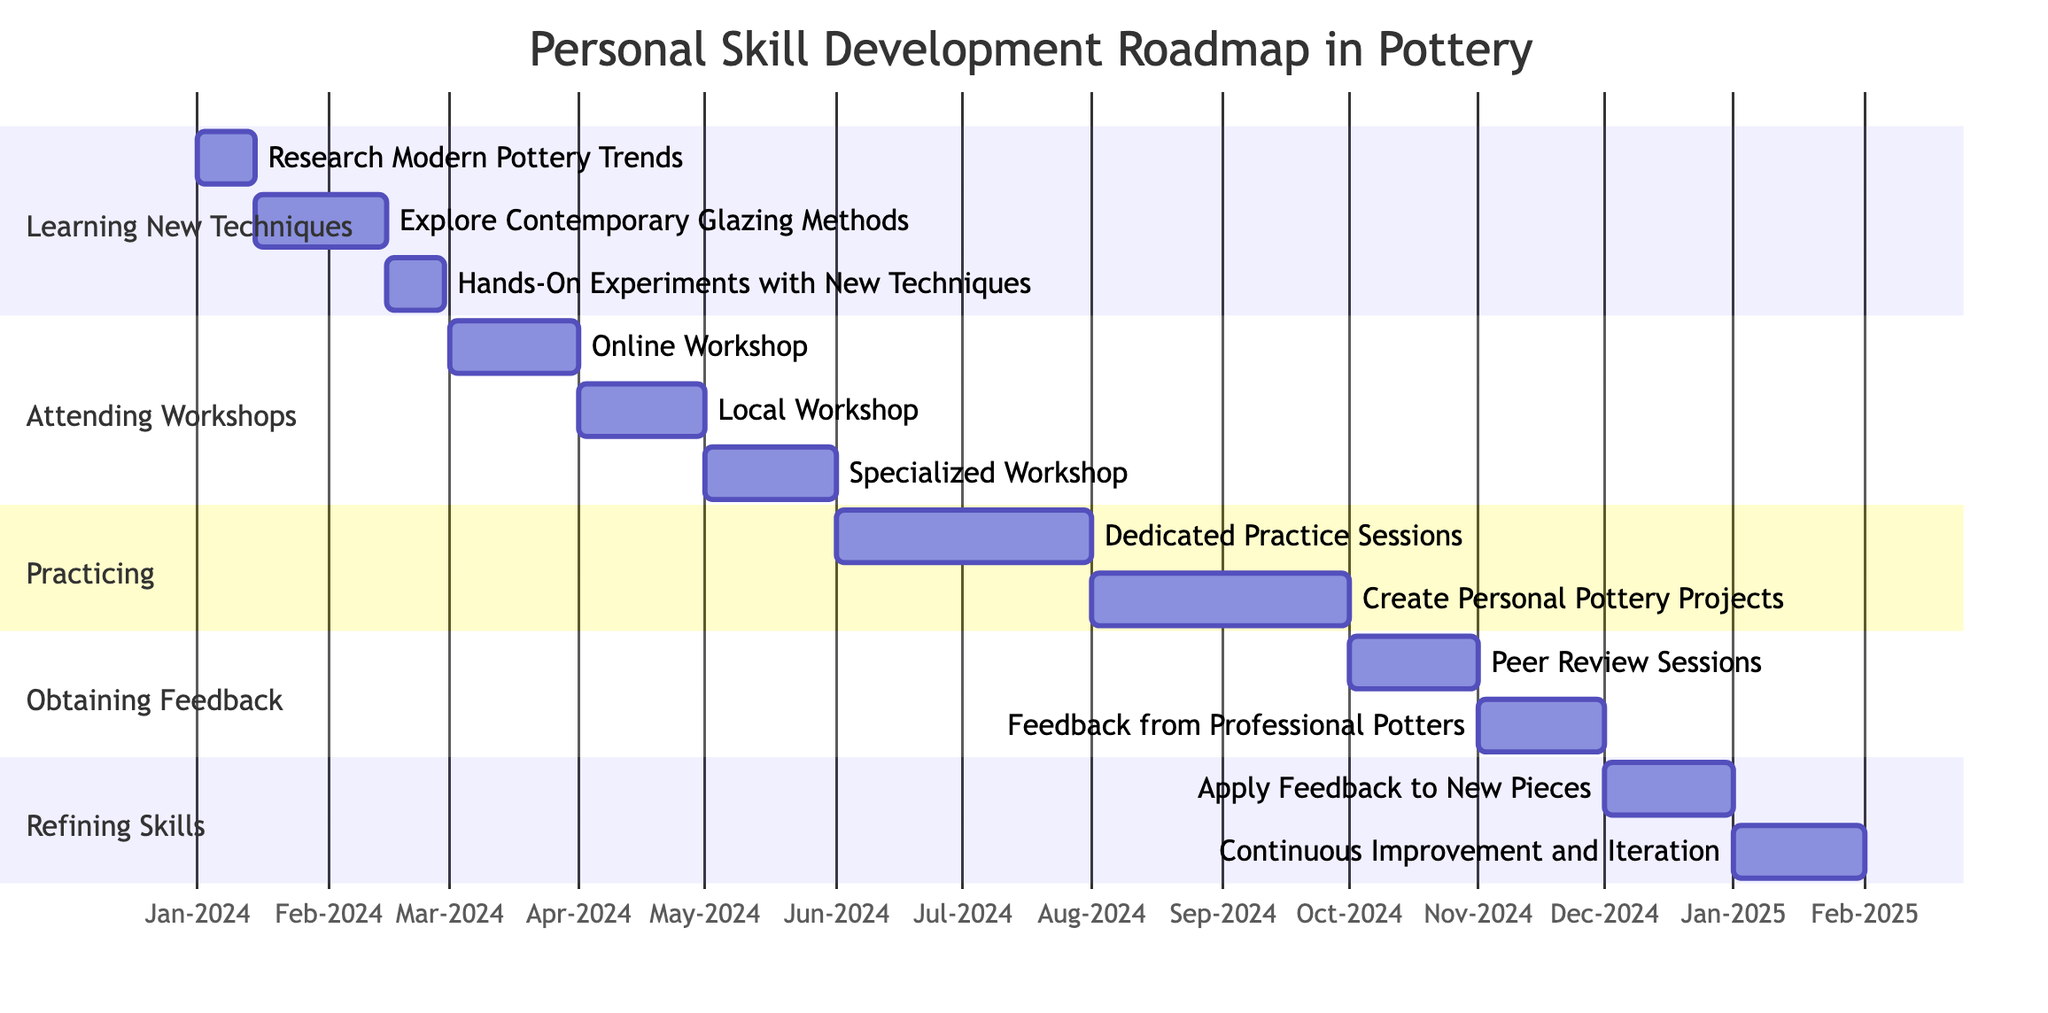What is the duration for the 'Learning New Techniques' section? The duration for the 'Learning New Techniques' section, as specified in the diagram, is 2 months.
Answer: 2 months How many tasks are in the 'Practicing' section? The 'Practicing' section contains 2 tasks: "Dedicated Practice Sessions" and "Create Personal Pottery Projects." Counting these gives a total of 2 tasks.
Answer: 2 What is the next task after 'Peer Review Sessions'? The task that follows 'Peer Review Sessions' is 'Feedback from Professional Potters' according to the timeline sequence laid out in the Gantt chart.
Answer: Feedback from Professional Potters How long does it take to attend all workshops listed? Each workshop in the 'Attending Workshops' section takes 1 month, and there are 3 workshops in total. Thus, the total duration for attending workshops is 3 months (1 month per workshop).
Answer: 3 months What is the starting date for 'Dedicated Practice Sessions'? The 'Dedicated Practice Sessions' start on June 1, 2024, based on the timeline specified in the Gantt chart.
Answer: June 1, 2024 What section follows 'Refining Skills' in the diagram? According to the structure of the Gantt chart, there are no additional sections following 'Refining Skills' as it is the final section.
Answer: None How long do the 'Hands-On Experiments with New Techniques' take? The duration for 'Hands-On Experiments with New Techniques' is specified as 2 weeks in the tasks listed under the 'Learning New Techniques' section.
Answer: 2 weeks How many months does 'Obtaining Feedback' take? The 'Obtaining Feedback' section has a specified duration of 2 months, which is derived from the total time allocated for that section in the Gantt chart.
Answer: 2 months What is the task duration for 'Online Workshop: Advanced Throwing Techniques'? The task duration for 'Online Workshop: Advanced Throwing Techniques' is stated as 1 month in the diagram's 'Attending Workshops' section.
Answer: 1 month 